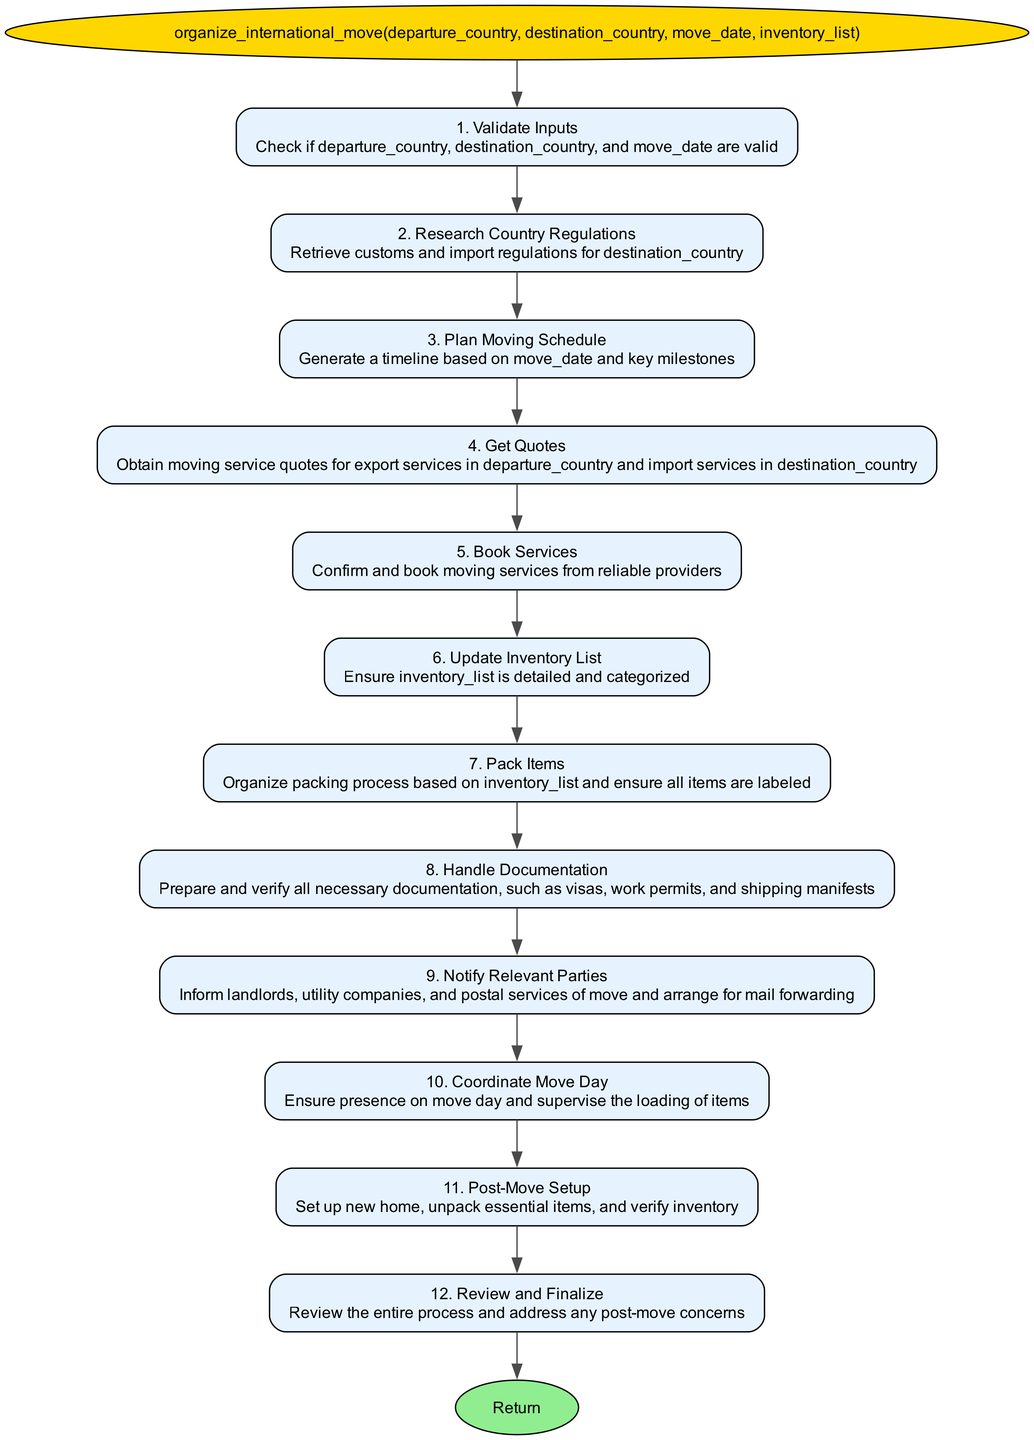What is the name of the function? The function name is displayed in the first node of the flowchart, labeled as "organize_international_move".
Answer: organize_international_move How many steps are in the flowchart? The flowchart contains twelve steps as indicated by the numbering in each step description.
Answer: 12 What is the first step in the process? The first step is labeled as "1. Validate Inputs," which refers to checking the validity of the departure country, destination country, and move date.
Answer: Validate Inputs Which step involves obtaining moving service quotes? The step that involves obtaining moving service quotes is labeled as "4. Get Quotes," detailing the need to acquire quotes for export and import services.
Answer: Get Quotes What action follows updating the inventory list? The action that follows updating the inventory list is "Pack Items," as per the flowchart's sequence from step six to seven.
Answer: Pack Items What is the last step in the flowchart? The last step is labeled "12. Review and Finalize," which indicates a review of the entire moving process and addressing any post-move concerns.
Answer: Review and Finalize What do you need to prepare in step eight? In step eight, the necessary documentation includes visas, work permits, and shipping manifests, which are crucial for managing the moving process.
Answer: Documentation Which step is responsible for informing landlords and utility companies? The step responsible for notifying landlords and utility companies is step nine, titled "Notify Relevant Parties."
Answer: Notify Relevant Parties Which two steps involve planning and organizing? Steps three and seven are both focused on planning and organizing: step three is "Plan Moving Schedule," while step seven is "Pack Items."
Answer: Plan Moving Schedule, Pack Items 